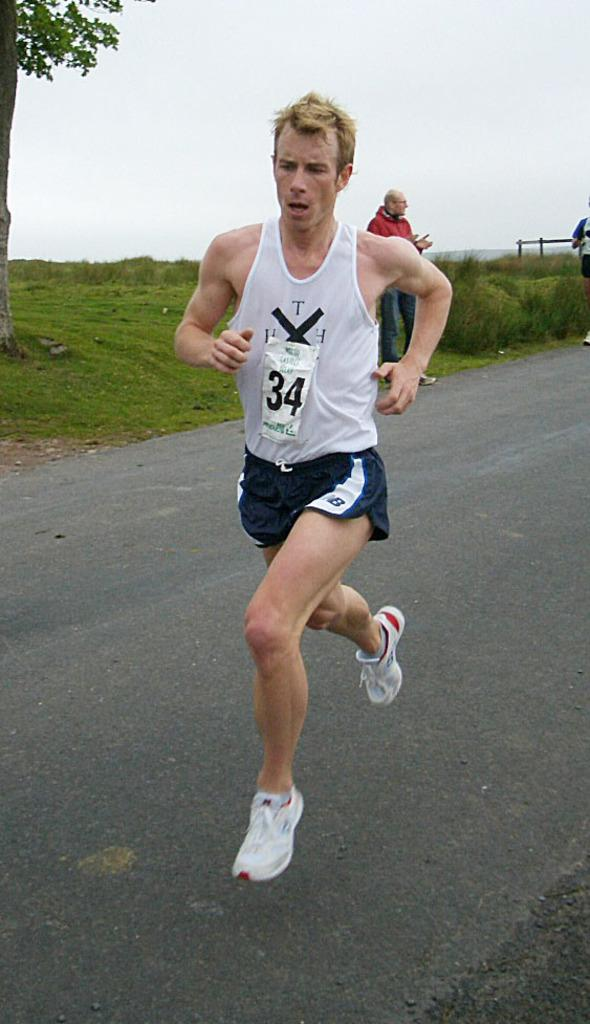<image>
Render a clear and concise summary of the photo. the number 34 on a sticker that is on a person 